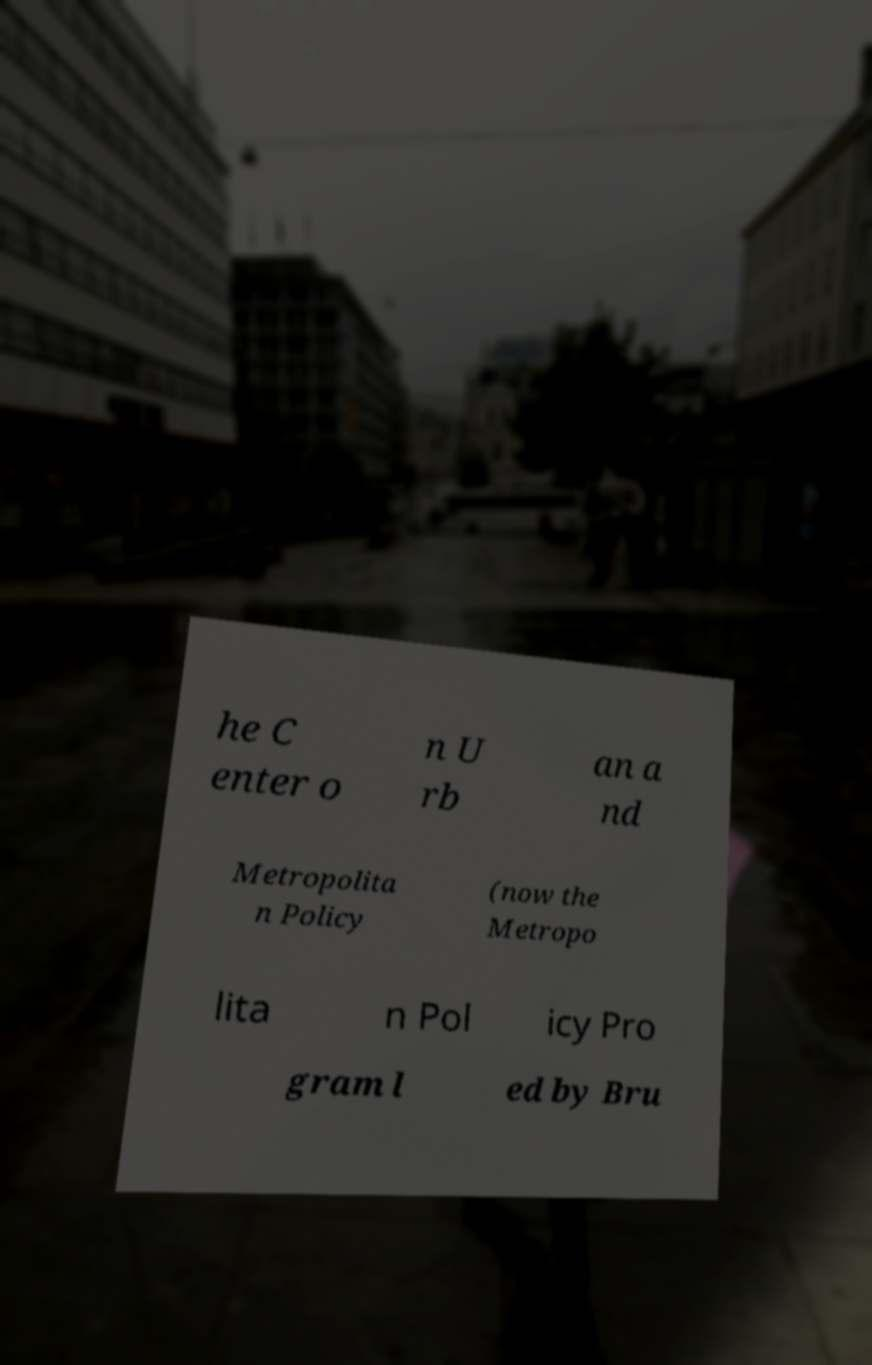Please read and relay the text visible in this image. What does it say? he C enter o n U rb an a nd Metropolita n Policy (now the Metropo lita n Pol icy Pro gram l ed by Bru 